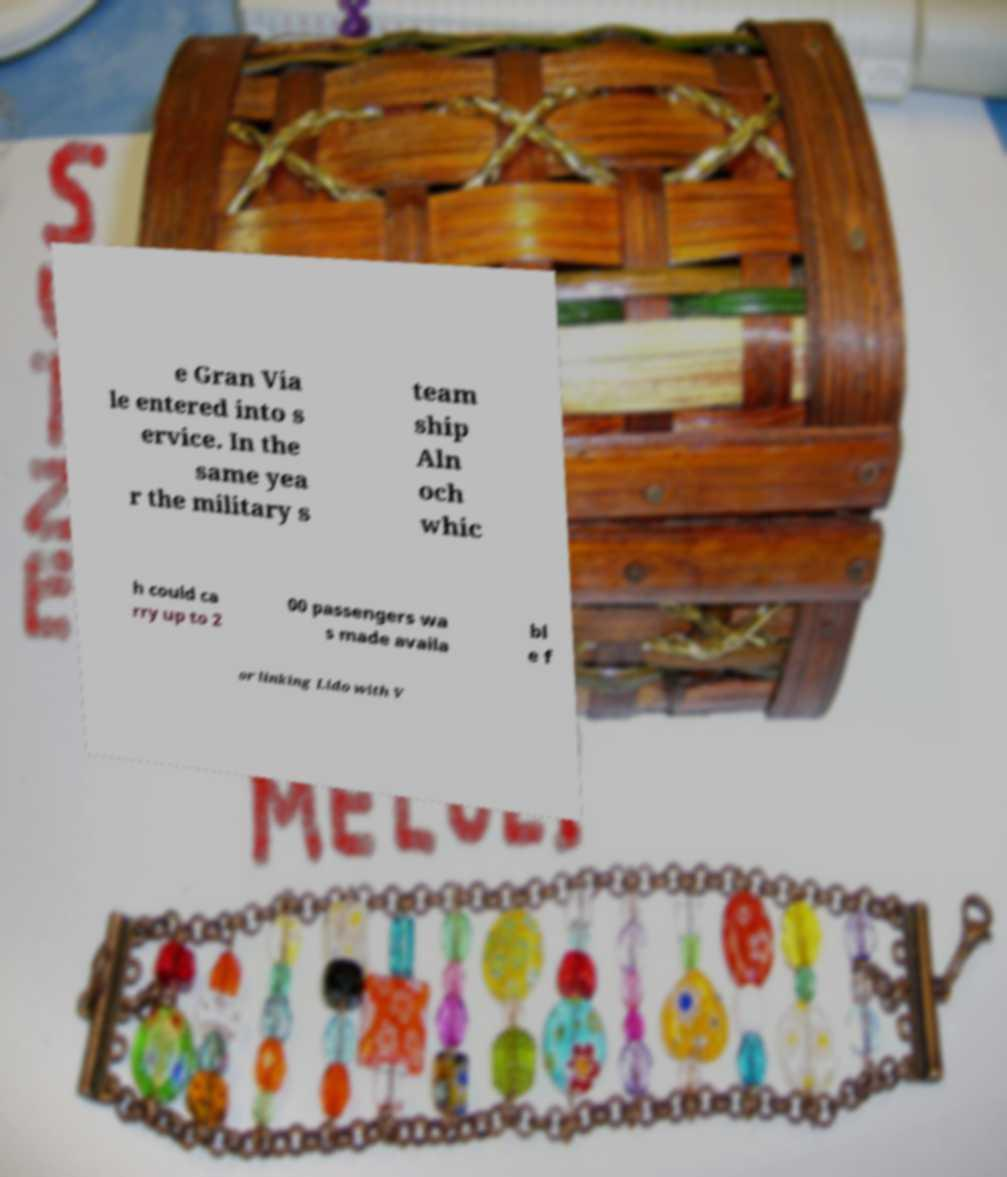There's text embedded in this image that I need extracted. Can you transcribe it verbatim? e Gran Via le entered into s ervice. In the same yea r the military s team ship Aln och whic h could ca rry up to 2 00 passengers wa s made availa bl e f or linking Lido with V 